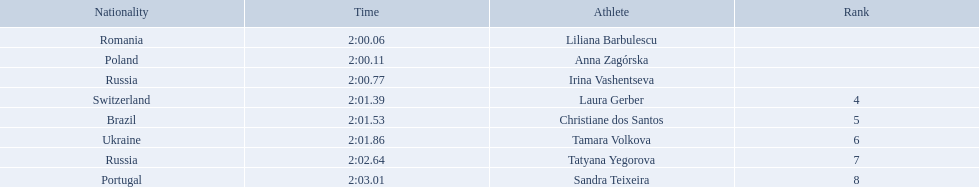What were all the finishing times? 2:00.06, 2:00.11, 2:00.77, 2:01.39, 2:01.53, 2:01.86, 2:02.64, 2:03.01. Which of these is anna zagorska's? 2:00.11. 